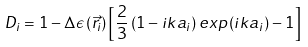Convert formula to latex. <formula><loc_0><loc_0><loc_500><loc_500>D _ { i } = 1 - \Delta \epsilon \left ( \vec { r } _ { i } \right ) \left [ \frac { 2 } { 3 } \left ( 1 - i k a _ { i } \right ) e x p \left ( i k a _ { i } \right ) - 1 \right ]</formula> 